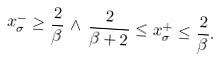Convert formula to latex. <formula><loc_0><loc_0><loc_500><loc_500>x _ { \sigma } ^ { - } \geq \frac { 2 } { \beta } \, \wedge \, \frac { 2 } { \beta + 2 } \leq x _ { \sigma } ^ { + } \leq \frac { 2 } { \beta } .</formula> 